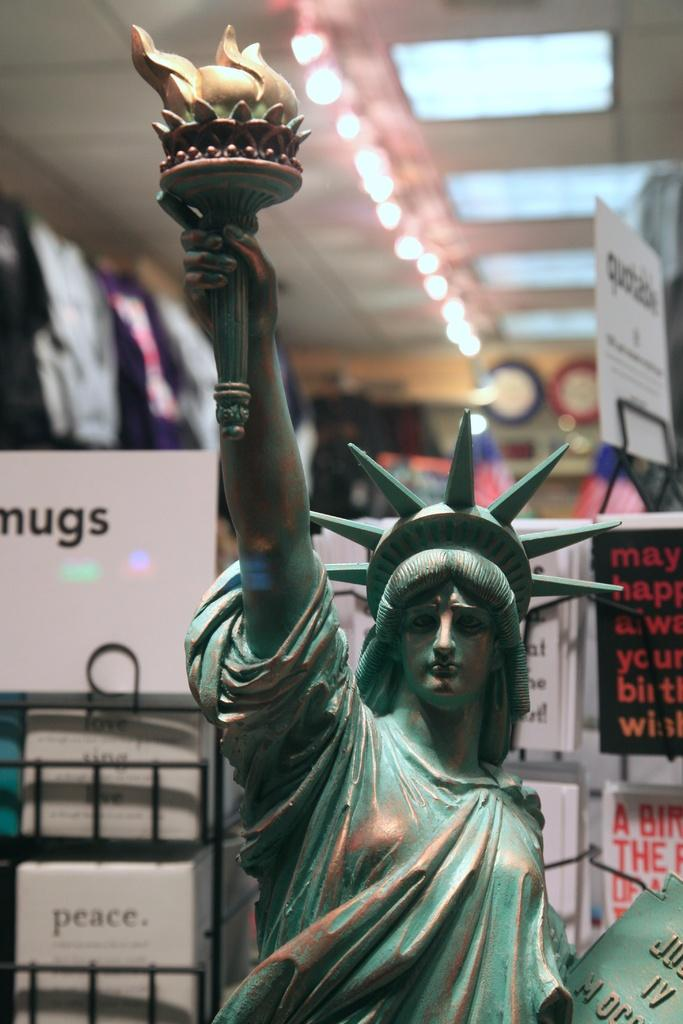What is the main subject in the center of the image? There is a statue in the center of the image. What can be seen in the background of the image? There are boards visible in the background of the image. What is located at the top of the image? There are lights at the top of the image. What type of smell can be detected from the statue in the image? There is no indication of a smell in the image, as it is a visual representation. 